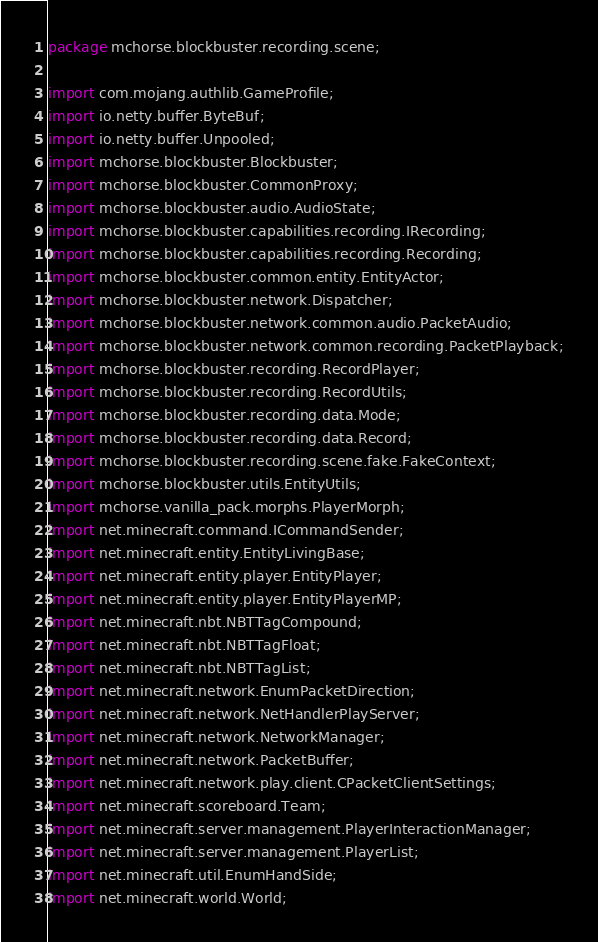Convert code to text. <code><loc_0><loc_0><loc_500><loc_500><_Java_>package mchorse.blockbuster.recording.scene;

import com.mojang.authlib.GameProfile;
import io.netty.buffer.ByteBuf;
import io.netty.buffer.Unpooled;
import mchorse.blockbuster.Blockbuster;
import mchorse.blockbuster.CommonProxy;
import mchorse.blockbuster.audio.AudioState;
import mchorse.blockbuster.capabilities.recording.IRecording;
import mchorse.blockbuster.capabilities.recording.Recording;
import mchorse.blockbuster.common.entity.EntityActor;
import mchorse.blockbuster.network.Dispatcher;
import mchorse.blockbuster.network.common.audio.PacketAudio;
import mchorse.blockbuster.network.common.recording.PacketPlayback;
import mchorse.blockbuster.recording.RecordPlayer;
import mchorse.blockbuster.recording.RecordUtils;
import mchorse.blockbuster.recording.data.Mode;
import mchorse.blockbuster.recording.data.Record;
import mchorse.blockbuster.recording.scene.fake.FakeContext;
import mchorse.blockbuster.utils.EntityUtils;
import mchorse.vanilla_pack.morphs.PlayerMorph;
import net.minecraft.command.ICommandSender;
import net.minecraft.entity.EntityLivingBase;
import net.minecraft.entity.player.EntityPlayer;
import net.minecraft.entity.player.EntityPlayerMP;
import net.minecraft.nbt.NBTTagCompound;
import net.minecraft.nbt.NBTTagFloat;
import net.minecraft.nbt.NBTTagList;
import net.minecraft.network.EnumPacketDirection;
import net.minecraft.network.NetHandlerPlayServer;
import net.minecraft.network.NetworkManager;
import net.minecraft.network.PacketBuffer;
import net.minecraft.network.play.client.CPacketClientSettings;
import net.minecraft.scoreboard.Team;
import net.minecraft.server.management.PlayerInteractionManager;
import net.minecraft.server.management.PlayerList;
import net.minecraft.util.EnumHandSide;
import net.minecraft.world.World;</code> 